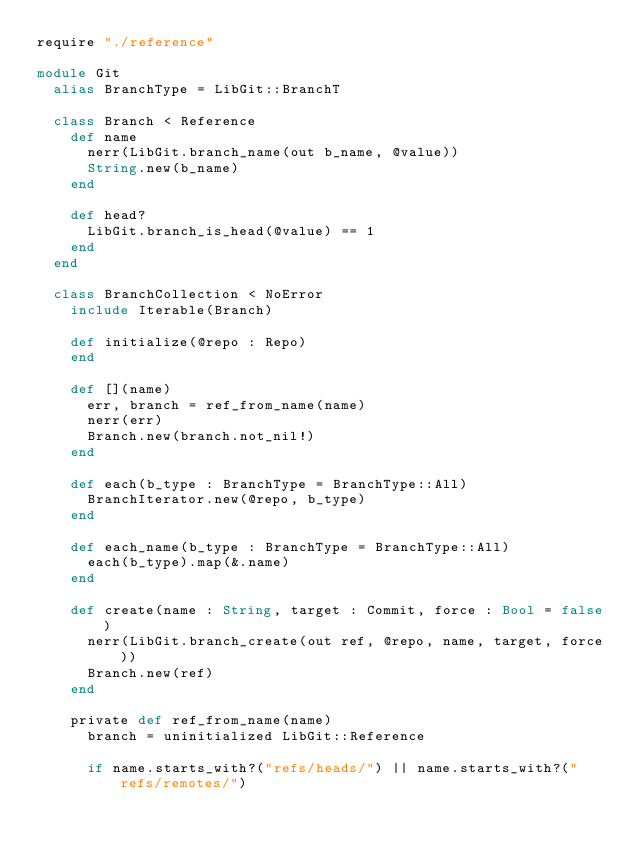Convert code to text. <code><loc_0><loc_0><loc_500><loc_500><_Crystal_>require "./reference"

module Git
  alias BranchType = LibGit::BranchT

  class Branch < Reference
    def name
      nerr(LibGit.branch_name(out b_name, @value))
      String.new(b_name)
    end

    def head?
      LibGit.branch_is_head(@value) == 1
    end
  end

  class BranchCollection < NoError
    include Iterable(Branch)

    def initialize(@repo : Repo)
    end

    def [](name)
      err, branch = ref_from_name(name)
      nerr(err)
      Branch.new(branch.not_nil!)
    end

    def each(b_type : BranchType = BranchType::All)
      BranchIterator.new(@repo, b_type)
    end

    def each_name(b_type : BranchType = BranchType::All)
      each(b_type).map(&.name)
    end

    def create(name : String, target : Commit, force : Bool = false)
      nerr(LibGit.branch_create(out ref, @repo, name, target, force))
      Branch.new(ref)
    end

    private def ref_from_name(name)
      branch = uninitialized LibGit::Reference

      if name.starts_with?("refs/heads/") || name.starts_with?("refs/remotes/")</code> 